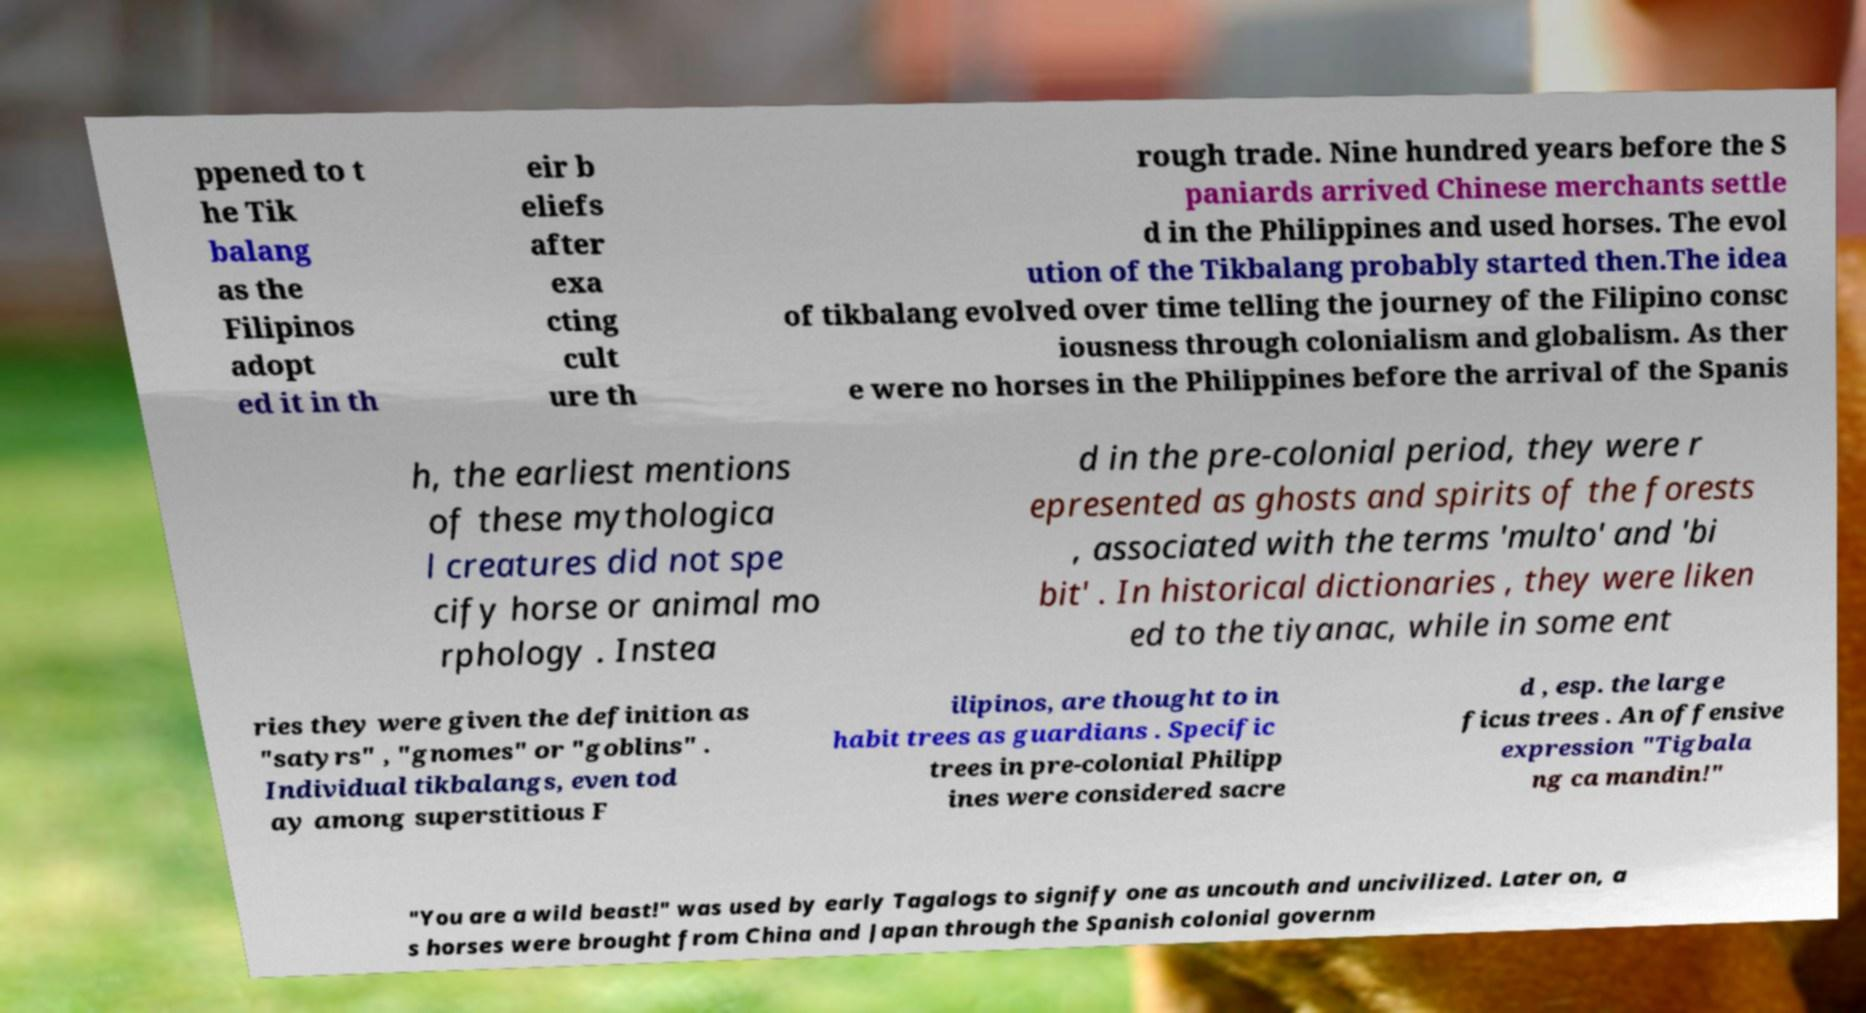Please read and relay the text visible in this image. What does it say? ppened to t he Tik balang as the Filipinos adopt ed it in th eir b eliefs after exa cting cult ure th rough trade. Nine hundred years before the S paniards arrived Chinese merchants settle d in the Philippines and used horses. The evol ution of the Tikbalang probably started then.The idea of tikbalang evolved over time telling the journey of the Filipino consc iousness through colonialism and globalism. As ther e were no horses in the Philippines before the arrival of the Spanis h, the earliest mentions of these mythologica l creatures did not spe cify horse or animal mo rphology . Instea d in the pre-colonial period, they were r epresented as ghosts and spirits of the forests , associated with the terms 'multo' and 'bi bit' . In historical dictionaries , they were liken ed to the tiyanac, while in some ent ries they were given the definition as "satyrs" , "gnomes" or "goblins" . Individual tikbalangs, even tod ay among superstitious F ilipinos, are thought to in habit trees as guardians . Specific trees in pre-colonial Philipp ines were considered sacre d , esp. the large ficus trees . An offensive expression "Tigbala ng ca mandin!" "You are a wild beast!" was used by early Tagalogs to signify one as uncouth and uncivilized. Later on, a s horses were brought from China and Japan through the Spanish colonial governm 